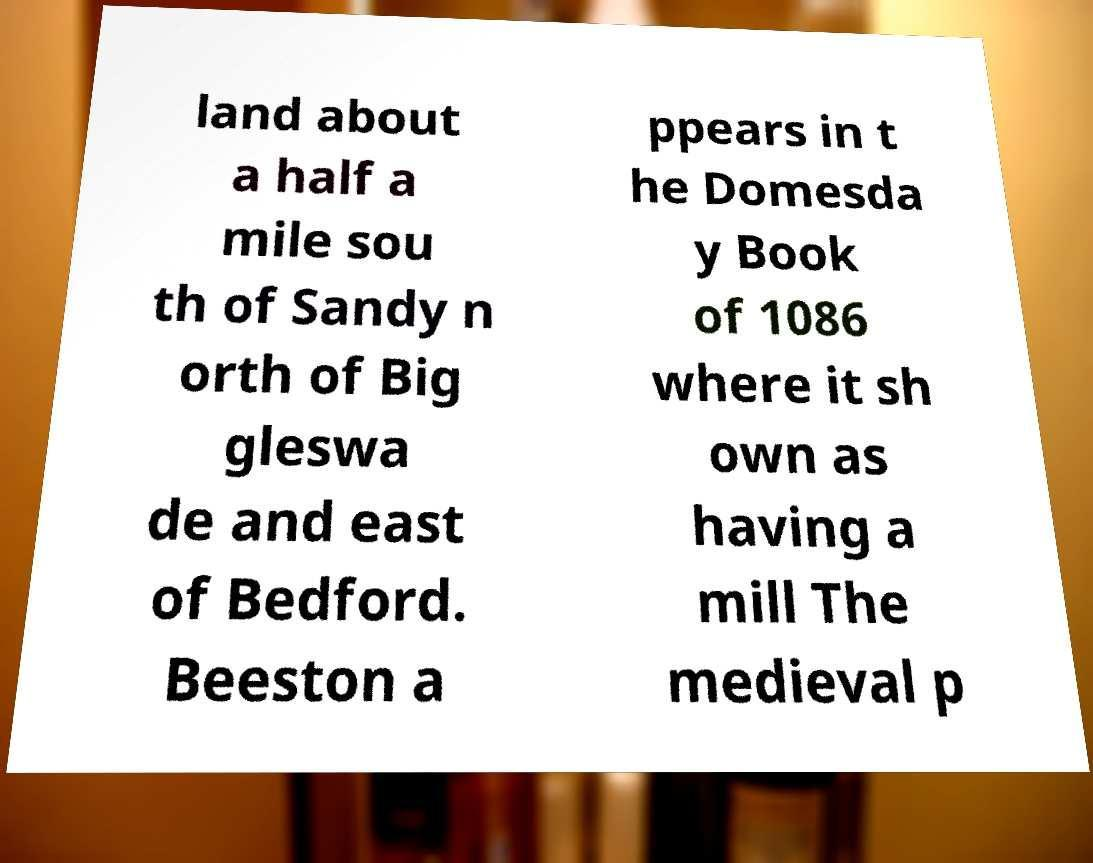Can you read and provide the text displayed in the image?This photo seems to have some interesting text. Can you extract and type it out for me? land about a half a mile sou th of Sandy n orth of Big gleswa de and east of Bedford. Beeston a ppears in t he Domesda y Book of 1086 where it sh own as having a mill The medieval p 